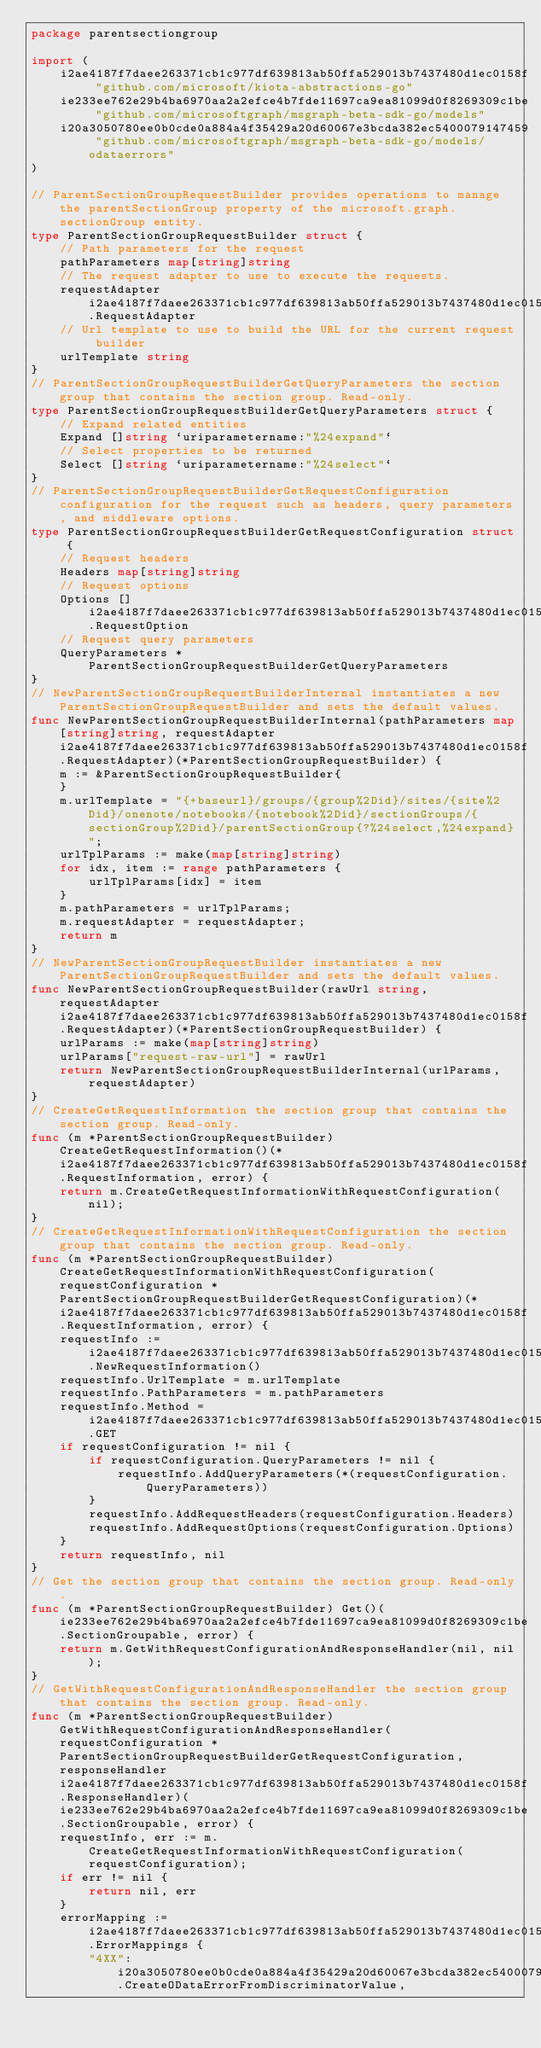<code> <loc_0><loc_0><loc_500><loc_500><_Go_>package parentsectiongroup

import (
    i2ae4187f7daee263371cb1c977df639813ab50ffa529013b7437480d1ec0158f "github.com/microsoft/kiota-abstractions-go"
    ie233ee762e29b4ba6970aa2a2efce4b7fde11697ca9ea81099d0f8269309c1be "github.com/microsoftgraph/msgraph-beta-sdk-go/models"
    i20a3050780ee0b0cde0a884a4f35429a20d60067e3bcda382ec5400079147459 "github.com/microsoftgraph/msgraph-beta-sdk-go/models/odataerrors"
)

// ParentSectionGroupRequestBuilder provides operations to manage the parentSectionGroup property of the microsoft.graph.sectionGroup entity.
type ParentSectionGroupRequestBuilder struct {
    // Path parameters for the request
    pathParameters map[string]string
    // The request adapter to use to execute the requests.
    requestAdapter i2ae4187f7daee263371cb1c977df639813ab50ffa529013b7437480d1ec0158f.RequestAdapter
    // Url template to use to build the URL for the current request builder
    urlTemplate string
}
// ParentSectionGroupRequestBuilderGetQueryParameters the section group that contains the section group. Read-only.
type ParentSectionGroupRequestBuilderGetQueryParameters struct {
    // Expand related entities
    Expand []string `uriparametername:"%24expand"`
    // Select properties to be returned
    Select []string `uriparametername:"%24select"`
}
// ParentSectionGroupRequestBuilderGetRequestConfiguration configuration for the request such as headers, query parameters, and middleware options.
type ParentSectionGroupRequestBuilderGetRequestConfiguration struct {
    // Request headers
    Headers map[string]string
    // Request options
    Options []i2ae4187f7daee263371cb1c977df639813ab50ffa529013b7437480d1ec0158f.RequestOption
    // Request query parameters
    QueryParameters *ParentSectionGroupRequestBuilderGetQueryParameters
}
// NewParentSectionGroupRequestBuilderInternal instantiates a new ParentSectionGroupRequestBuilder and sets the default values.
func NewParentSectionGroupRequestBuilderInternal(pathParameters map[string]string, requestAdapter i2ae4187f7daee263371cb1c977df639813ab50ffa529013b7437480d1ec0158f.RequestAdapter)(*ParentSectionGroupRequestBuilder) {
    m := &ParentSectionGroupRequestBuilder{
    }
    m.urlTemplate = "{+baseurl}/groups/{group%2Did}/sites/{site%2Did}/onenote/notebooks/{notebook%2Did}/sectionGroups/{sectionGroup%2Did}/parentSectionGroup{?%24select,%24expand}";
    urlTplParams := make(map[string]string)
    for idx, item := range pathParameters {
        urlTplParams[idx] = item
    }
    m.pathParameters = urlTplParams;
    m.requestAdapter = requestAdapter;
    return m
}
// NewParentSectionGroupRequestBuilder instantiates a new ParentSectionGroupRequestBuilder and sets the default values.
func NewParentSectionGroupRequestBuilder(rawUrl string, requestAdapter i2ae4187f7daee263371cb1c977df639813ab50ffa529013b7437480d1ec0158f.RequestAdapter)(*ParentSectionGroupRequestBuilder) {
    urlParams := make(map[string]string)
    urlParams["request-raw-url"] = rawUrl
    return NewParentSectionGroupRequestBuilderInternal(urlParams, requestAdapter)
}
// CreateGetRequestInformation the section group that contains the section group. Read-only.
func (m *ParentSectionGroupRequestBuilder) CreateGetRequestInformation()(*i2ae4187f7daee263371cb1c977df639813ab50ffa529013b7437480d1ec0158f.RequestInformation, error) {
    return m.CreateGetRequestInformationWithRequestConfiguration(nil);
}
// CreateGetRequestInformationWithRequestConfiguration the section group that contains the section group. Read-only.
func (m *ParentSectionGroupRequestBuilder) CreateGetRequestInformationWithRequestConfiguration(requestConfiguration *ParentSectionGroupRequestBuilderGetRequestConfiguration)(*i2ae4187f7daee263371cb1c977df639813ab50ffa529013b7437480d1ec0158f.RequestInformation, error) {
    requestInfo := i2ae4187f7daee263371cb1c977df639813ab50ffa529013b7437480d1ec0158f.NewRequestInformation()
    requestInfo.UrlTemplate = m.urlTemplate
    requestInfo.PathParameters = m.pathParameters
    requestInfo.Method = i2ae4187f7daee263371cb1c977df639813ab50ffa529013b7437480d1ec0158f.GET
    if requestConfiguration != nil {
        if requestConfiguration.QueryParameters != nil {
            requestInfo.AddQueryParameters(*(requestConfiguration.QueryParameters))
        }
        requestInfo.AddRequestHeaders(requestConfiguration.Headers)
        requestInfo.AddRequestOptions(requestConfiguration.Options)
    }
    return requestInfo, nil
}
// Get the section group that contains the section group. Read-only.
func (m *ParentSectionGroupRequestBuilder) Get()(ie233ee762e29b4ba6970aa2a2efce4b7fde11697ca9ea81099d0f8269309c1be.SectionGroupable, error) {
    return m.GetWithRequestConfigurationAndResponseHandler(nil, nil);
}
// GetWithRequestConfigurationAndResponseHandler the section group that contains the section group. Read-only.
func (m *ParentSectionGroupRequestBuilder) GetWithRequestConfigurationAndResponseHandler(requestConfiguration *ParentSectionGroupRequestBuilderGetRequestConfiguration, responseHandler i2ae4187f7daee263371cb1c977df639813ab50ffa529013b7437480d1ec0158f.ResponseHandler)(ie233ee762e29b4ba6970aa2a2efce4b7fde11697ca9ea81099d0f8269309c1be.SectionGroupable, error) {
    requestInfo, err := m.CreateGetRequestInformationWithRequestConfiguration(requestConfiguration);
    if err != nil {
        return nil, err
    }
    errorMapping := i2ae4187f7daee263371cb1c977df639813ab50ffa529013b7437480d1ec0158f.ErrorMappings {
        "4XX": i20a3050780ee0b0cde0a884a4f35429a20d60067e3bcda382ec5400079147459.CreateODataErrorFromDiscriminatorValue,</code> 